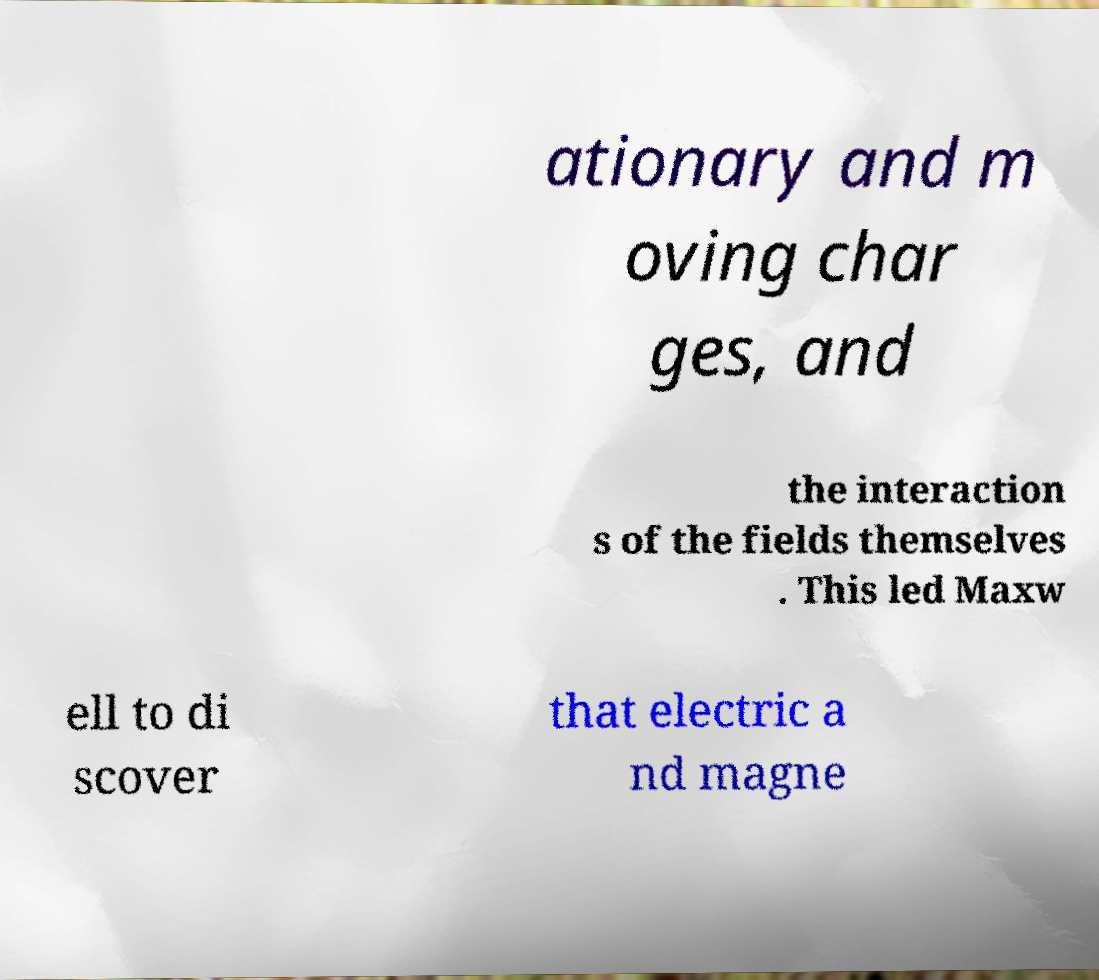Could you assist in decoding the text presented in this image and type it out clearly? ationary and m oving char ges, and the interaction s of the fields themselves . This led Maxw ell to di scover that electric a nd magne 